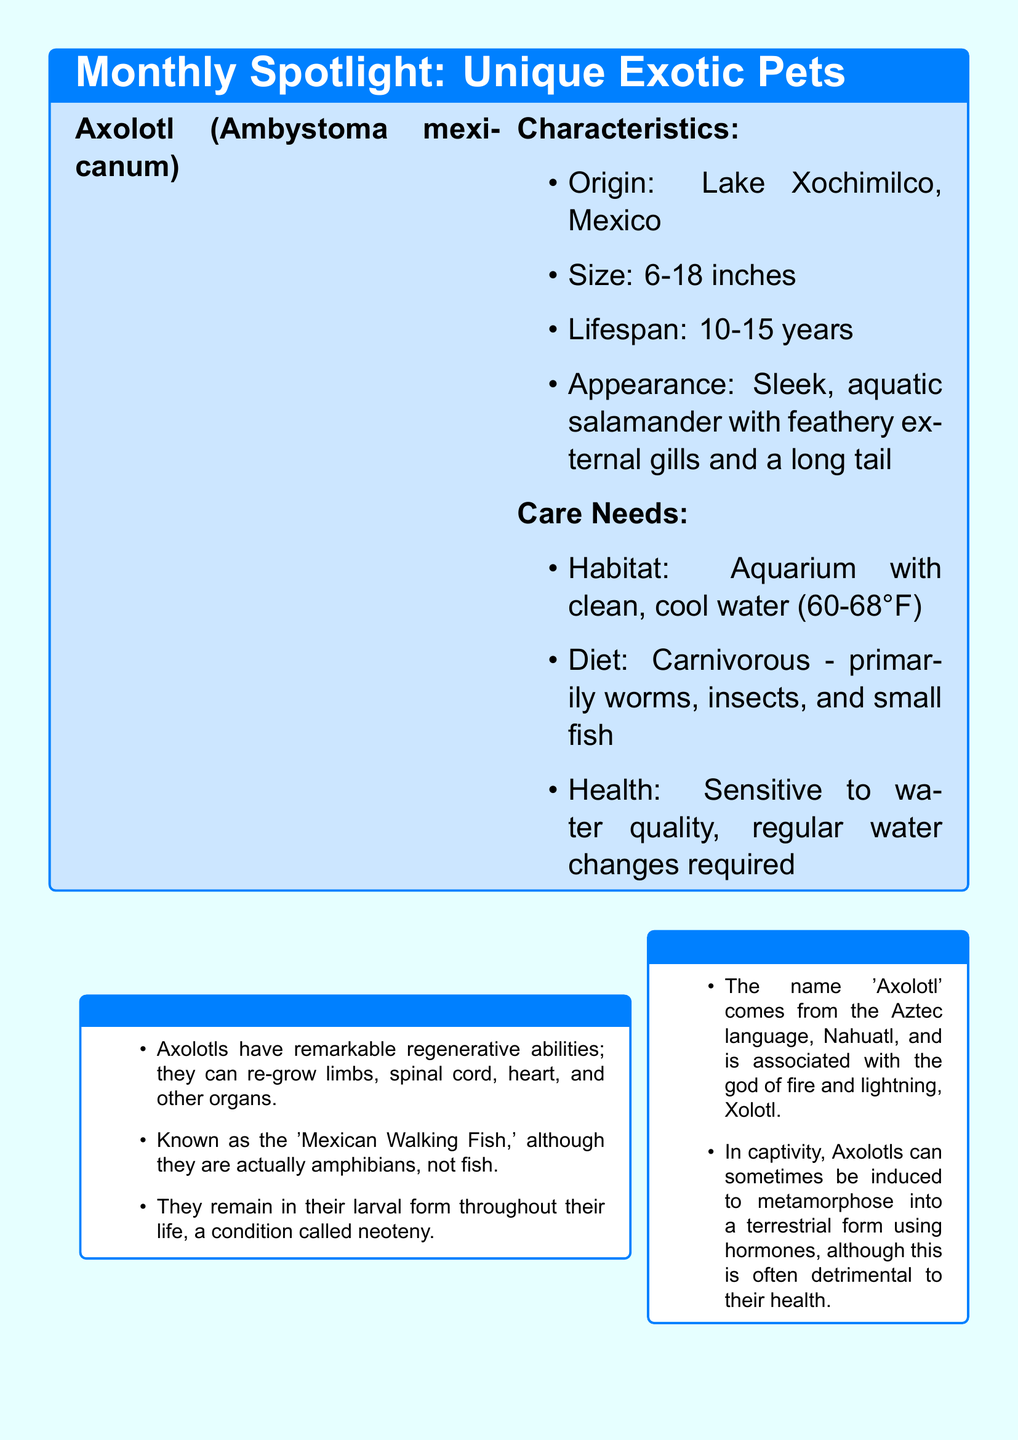What is the scientific name of the Axolotl? The scientific name of the Axolotl is stated in the document as Ambystoma mexicanum.
Answer: Ambystoma mexicanum Where is the Axolotl originally from? The document mentions that the Axolotl originates from Lake Xochimilco, Mexico.
Answer: Lake Xochimilco, Mexico What is the lifespan of an Axolotl? The lifespan of the Axolotl is provided in the care needs section as 10-15 years.
Answer: 10-15 years What is one of the main care requirements for an Axolotl's habitat? The document specifies that an Axolotl requires an aquarium with clean, cool water at a certain temperature.
Answer: Clean, cool water (60-68°F) Which amphibian is known as the 'Mexican Walking Fish'? The 'Mexican Walking Fish' is referred to in the document as the Axolotl.
Answer: Axolotl What unique ability do Axolotls possess? The document states that Axolotls have remarkable regenerative abilities, which include re-growing limbs and organs.
Answer: Regenerative abilities Who provided a pet owner’s perspective on living with an Axolotl? The pet owner’s perspective was provided by Maria Sanchez, as mentioned in the document.
Answer: Maria Sanchez What type of diet does an Axolotl have? The diet of an Axolotl is classified as carnivorous, with specifics given in the care needs section.
Answer: Carnivorous Which language does the name 'Axolotl' come from? The document states that the name 'Axolotl' comes from the Aztec language, Nahuatl.
Answer: Nahuatl 